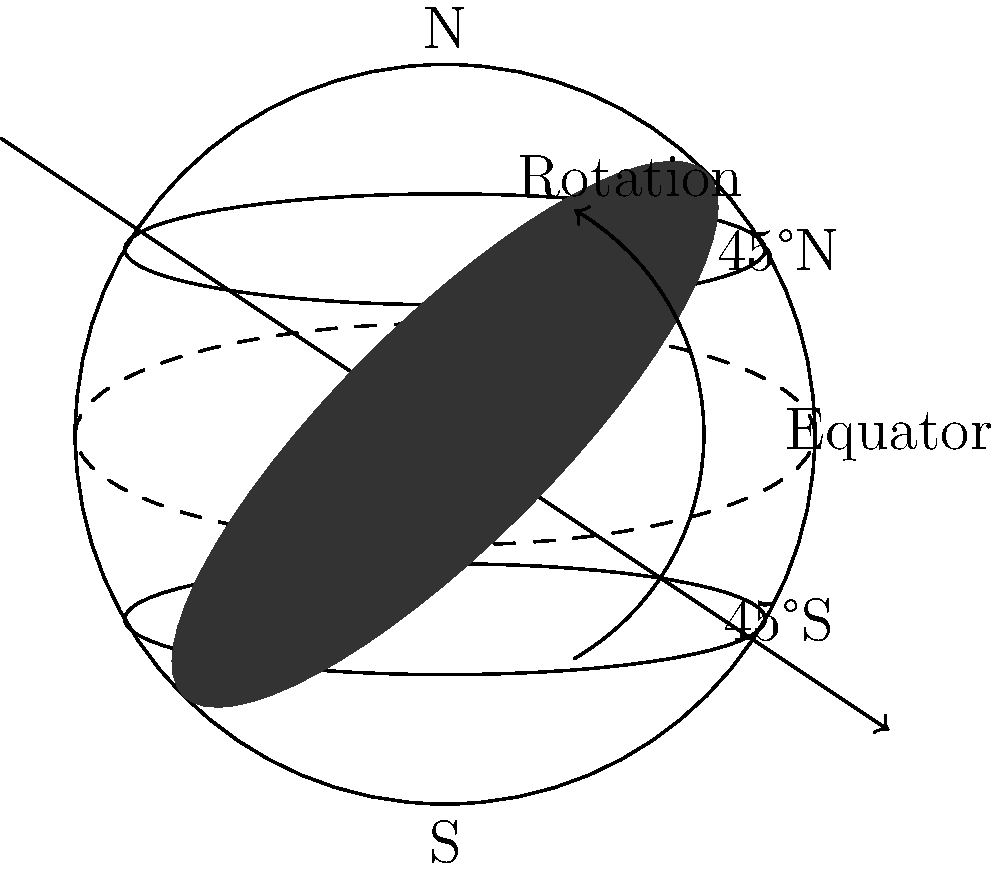As a savvy pop star looking to diversify your investments, you're considering funding a global concert tour. Understanding day/night cycles across different latitudes is crucial for planning outdoor events. How does the Earth's rotation affect the duration of daylight at 45°N latitude compared to the equator during the summer solstice? Let's break this down step-by-step:

1) The Earth rotates on its axis, which is tilted at approximately 23.5° relative to its orbital plane.

2) During the summer solstice in the Northern Hemisphere:
   - The North Pole is tilted towards the Sun
   - The equator receives about 12 hours of daylight
   - Locations north of the equator experience more than 12 hours of daylight

3) At the equator:
   - The Sun's path is always nearly perpendicular to the horizon
   - Day and night are almost equal in length year-round
   - Daylight duration ≈ 12 hours

4) At 45°N latitude:
   - The Sun's path is more oblique to the horizon
   - During summer, the Sun is above the horizon for a longer period
   - The duration of daylight is longer than at the equator

5) To calculate the daylight duration at 45°N during summer solstice:
   - Use the equation: $\cos(h) = -\tan(\phi)\tan(\delta)$
   - Where $h$ is the hour angle, $\phi$ is the latitude, and $\delta$ is the Sun's declination
   - At summer solstice, $\delta ≈ 23.5°$
   - For 45°N: $\cos(h) = -\tan(45°)\tan(23.5°) ≈ -0.4142$
   - $h ≈ 114.2°$

6) Convert the hour angle to time:
   - Daylight duration = $2h / 15° \text{ per hour} ≈ 15.2$ hours

Therefore, at 45°N latitude during the summer solstice, there are approximately 15.2 hours of daylight, which is about 3.2 hours more than at the equator.
Answer: 3.2 hours longer 